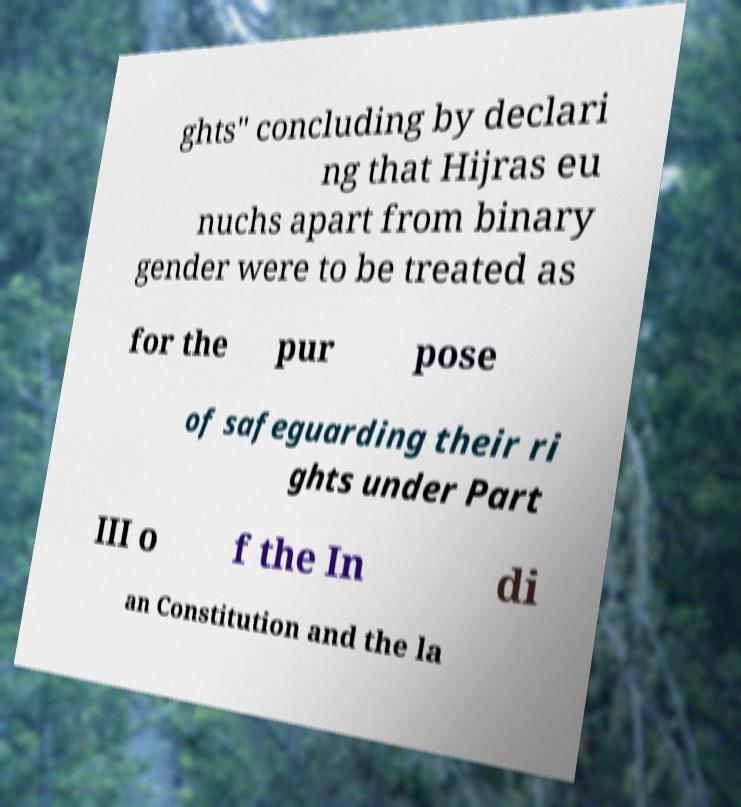I need the written content from this picture converted into text. Can you do that? ghts" concluding by declari ng that Hijras eu nuchs apart from binary gender were to be treated as for the pur pose of safeguarding their ri ghts under Part III o f the In di an Constitution and the la 